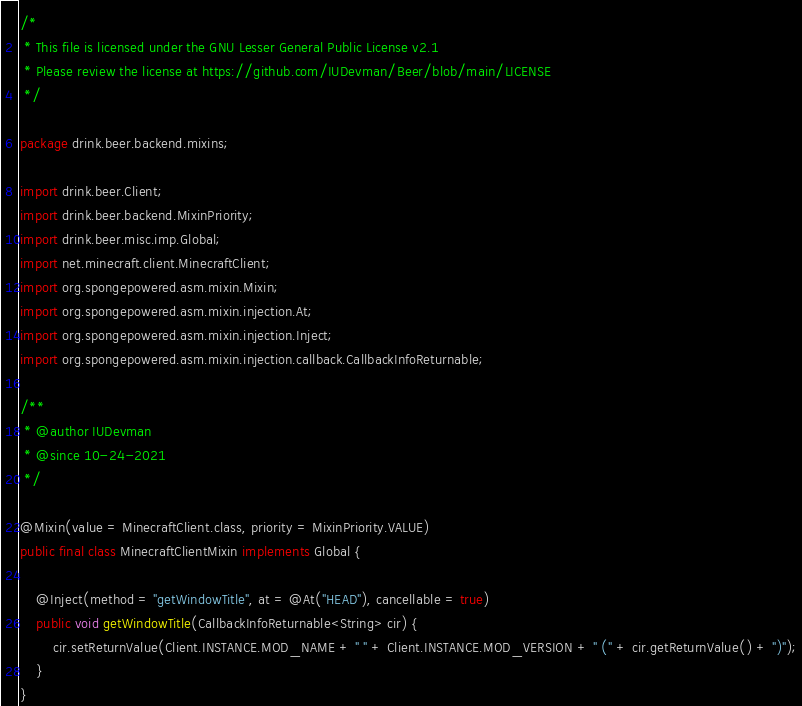<code> <loc_0><loc_0><loc_500><loc_500><_Java_>/*
 * This file is licensed under the GNU Lesser General Public License v2.1
 * Please review the license at https://github.com/IUDevman/Beer/blob/main/LICENSE
 */

package drink.beer.backend.mixins;

import drink.beer.Client;
import drink.beer.backend.MixinPriority;
import drink.beer.misc.imp.Global;
import net.minecraft.client.MinecraftClient;
import org.spongepowered.asm.mixin.Mixin;
import org.spongepowered.asm.mixin.injection.At;
import org.spongepowered.asm.mixin.injection.Inject;
import org.spongepowered.asm.mixin.injection.callback.CallbackInfoReturnable;

/**
 * @author IUDevman
 * @since 10-24-2021
 */

@Mixin(value = MinecraftClient.class, priority = MixinPriority.VALUE)
public final class MinecraftClientMixin implements Global {

    @Inject(method = "getWindowTitle", at = @At("HEAD"), cancellable = true)
    public void getWindowTitle(CallbackInfoReturnable<String> cir) {
        cir.setReturnValue(Client.INSTANCE.MOD_NAME + " " + Client.INSTANCE.MOD_VERSION + " (" + cir.getReturnValue() + ")");
    }
}
</code> 